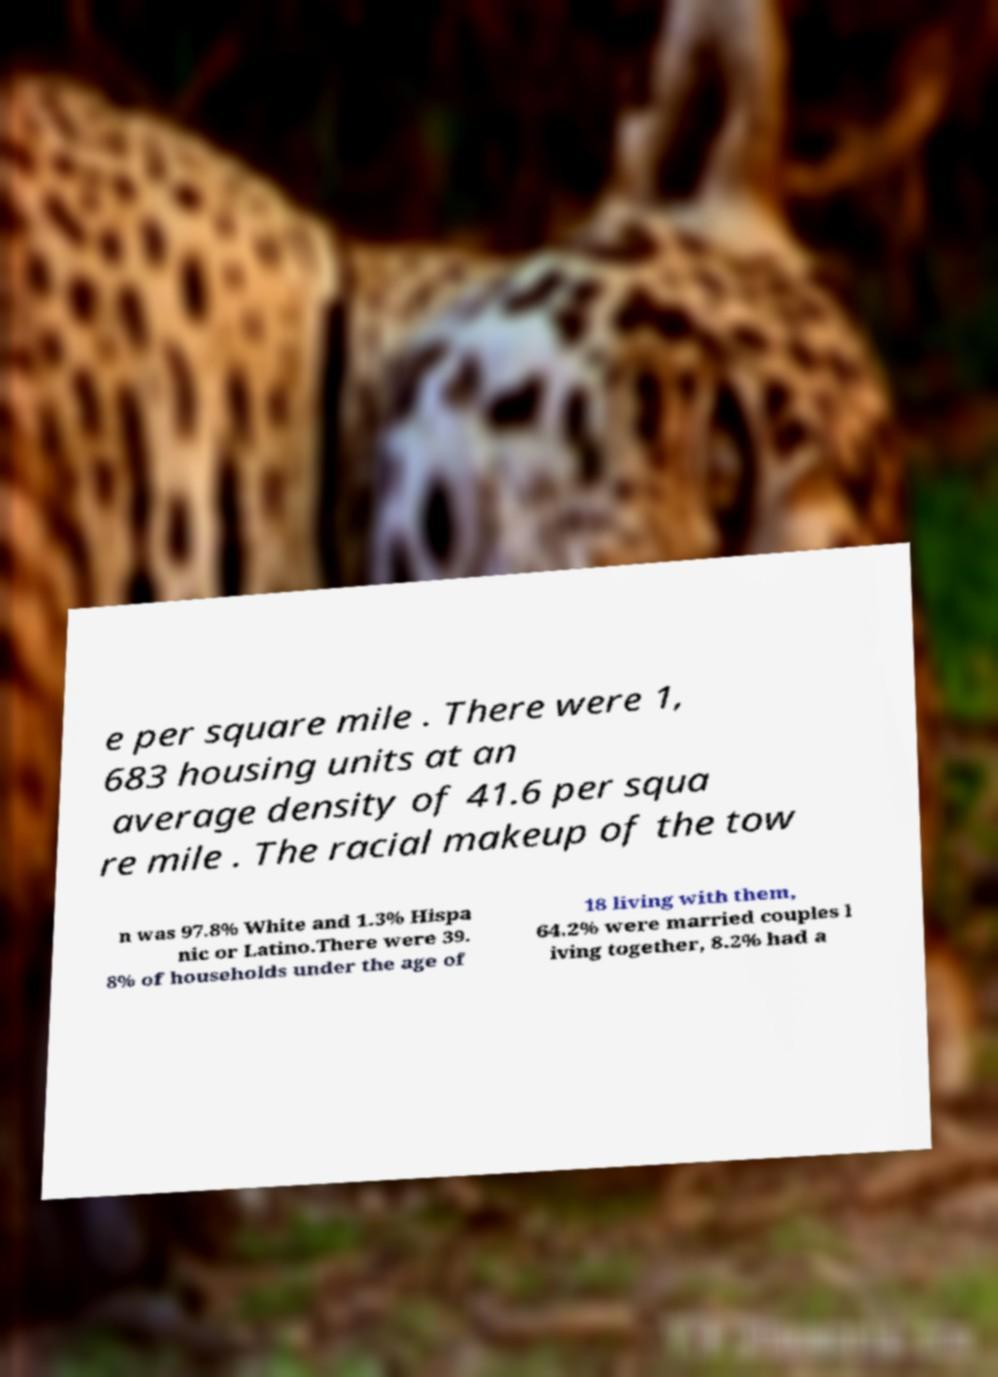What messages or text are displayed in this image? I need them in a readable, typed format. e per square mile . There were 1, 683 housing units at an average density of 41.6 per squa re mile . The racial makeup of the tow n was 97.8% White and 1.3% Hispa nic or Latino.There were 39. 8% of households under the age of 18 living with them, 64.2% were married couples l iving together, 8.2% had a 